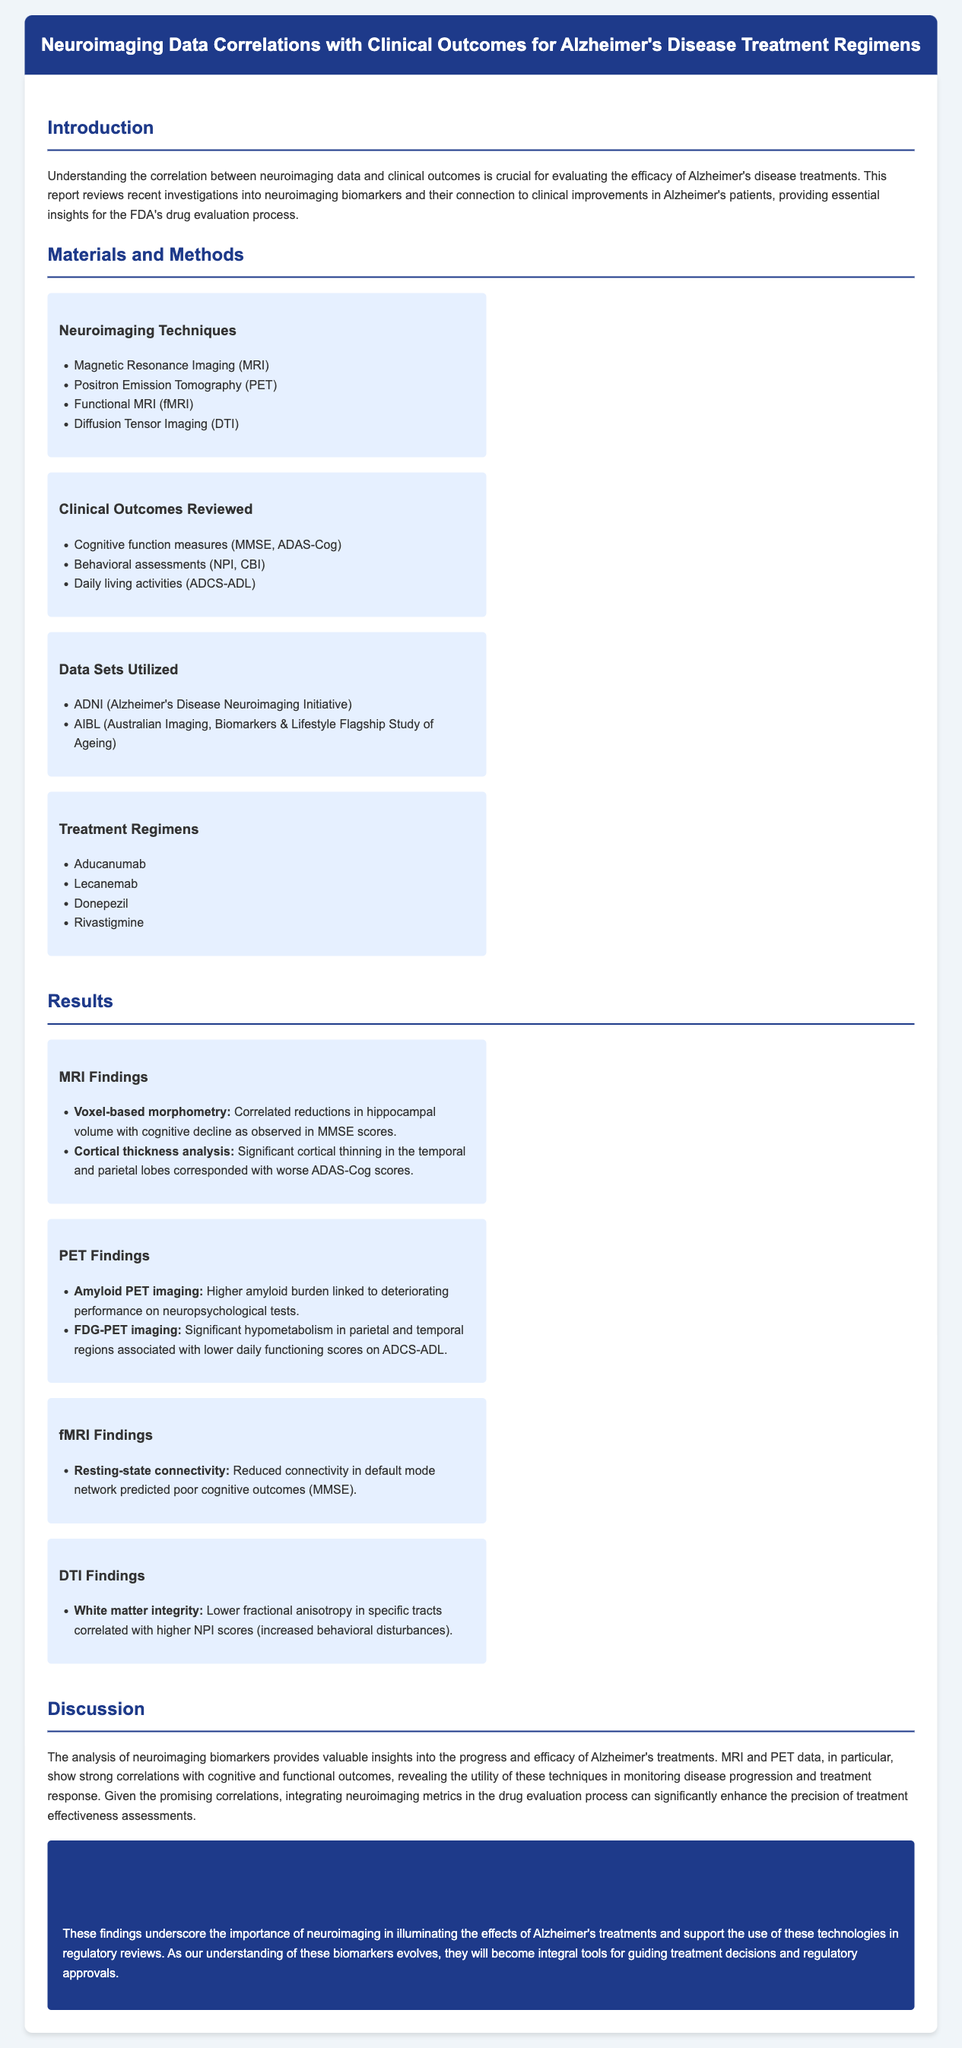What are the neuroimaging techniques used? The document lists specific neuroimaging techniques in the "Materials and Methods" section.
Answer: MRI, PET, fMRI, DTI Which treatment regimens are mentioned? The document has listed treatment regimens in the "Materials and Methods" section.
Answer: Aducanumab, Lecanemab, Donepezil, Rivastigmine What significant correlation was found with MMSE scores? The results indicate that voxel-based morphometry correlated reductions in hippocampal volume with cognitive decline as observed in MMSE scores.
Answer: Reductions in hippocampal volume How does higher amyloid burden affect neuropsychological performance? The report states that higher amyloid burden is linked to deteriorating performance on neuropsychological tests.
Answer: Deteriorating performance Which region showed significant hypometabolism associated with lower daily functioning scores? The PET findings highlight significant hypometabolism in specific regions related to ADCS-ADL scores.
Answer: Parietal and temporal regions What method was used to assess white matter integrity? The document mentions a specific imaging technique that evaluates white matter integrity in the results section.
Answer: DTI What conclusion is drawn about neuroimaging biomarkers? The conclusion discusses the role of neuroimaging in the context of Alzheimer's treatments and regulatory evaluations.
Answer: Integral tools for guiding treatment decisions What is the correlation between resting-state connectivity and cognitive outcomes? The fMRI findings suggest reduced connectivity in a specific network predicts poor cognitive outcomes.
Answer: Poor cognitive outcomes (MMSE) 